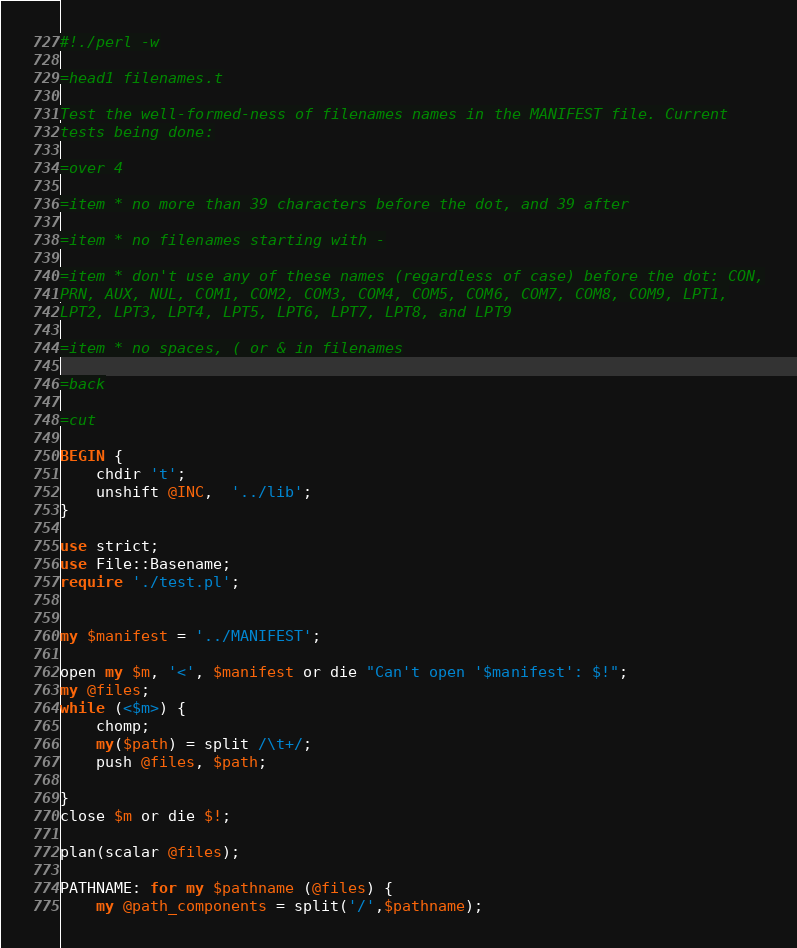<code> <loc_0><loc_0><loc_500><loc_500><_Perl_>#!./perl -w

=head1 filenames.t

Test the well-formed-ness of filenames names in the MANIFEST file. Current
tests being done:

=over 4

=item * no more than 39 characters before the dot, and 39 after

=item * no filenames starting with -

=item * don't use any of these names (regardless of case) before the dot: CON,
PRN, AUX, NUL, COM1, COM2, COM3, COM4, COM5, COM6, COM7, COM8, COM9, LPT1,
LPT2, LPT3, LPT4, LPT5, LPT6, LPT7, LPT8, and LPT9

=item * no spaces, ( or & in filenames

=back

=cut

BEGIN {
    chdir 't';
    unshift @INC,  '../lib';
}

use strict;
use File::Basename;
require './test.pl';


my $manifest = '../MANIFEST';

open my $m, '<', $manifest or die "Can't open '$manifest': $!";
my @files;
while (<$m>) {
    chomp;
    my($path) = split /\t+/;
    push @files, $path;

}
close $m or die $!;

plan(scalar @files);

PATHNAME: for my $pathname (@files) {
    my @path_components = split('/',$pathname);</code> 